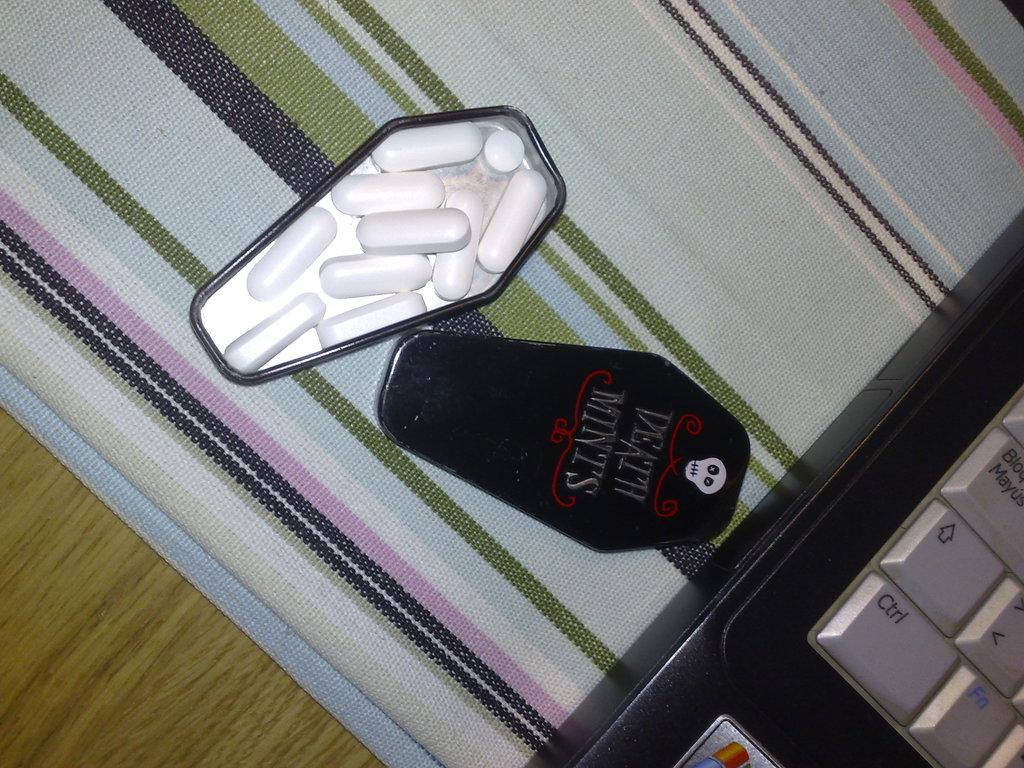Provide a one-sentence caption for the provided image. A mint tin in the shape of a coffin has death mints written on the lid. 